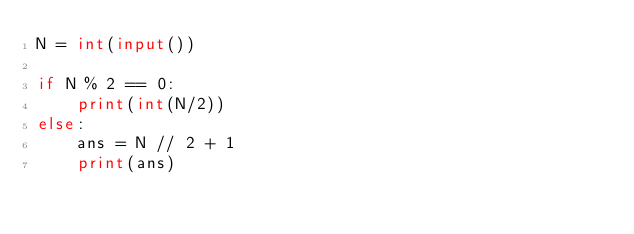Convert code to text. <code><loc_0><loc_0><loc_500><loc_500><_Python_>N = int(input())

if N % 2 == 0:
    print(int(N/2))
else:
    ans = N // 2 + 1
    print(ans)
</code> 